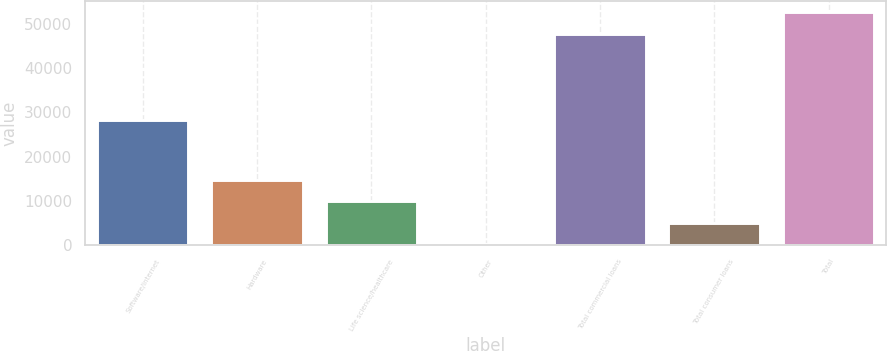Convert chart. <chart><loc_0><loc_0><loc_500><loc_500><bar_chart><fcel>Software/internet<fcel>Hardware<fcel>Life science/healthcare<fcel>Other<fcel>Total commercial loans<fcel>Total consumer loans<fcel>Total<nl><fcel>28245<fcel>14810.6<fcel>9951.4<fcel>233<fcel>47702<fcel>5092.2<fcel>52561.2<nl></chart> 